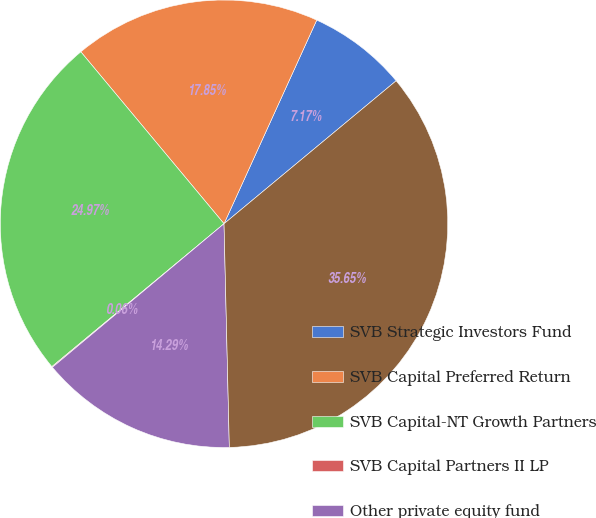Convert chart to OTSL. <chart><loc_0><loc_0><loc_500><loc_500><pie_chart><fcel>SVB Strategic Investors Fund<fcel>SVB Capital Preferred Return<fcel>SVB Capital-NT Growth Partners<fcel>SVB Capital Partners II LP<fcel>Other private equity fund<fcel>Total venture capital and<nl><fcel>7.17%<fcel>17.85%<fcel>24.97%<fcel>0.06%<fcel>14.29%<fcel>35.65%<nl></chart> 